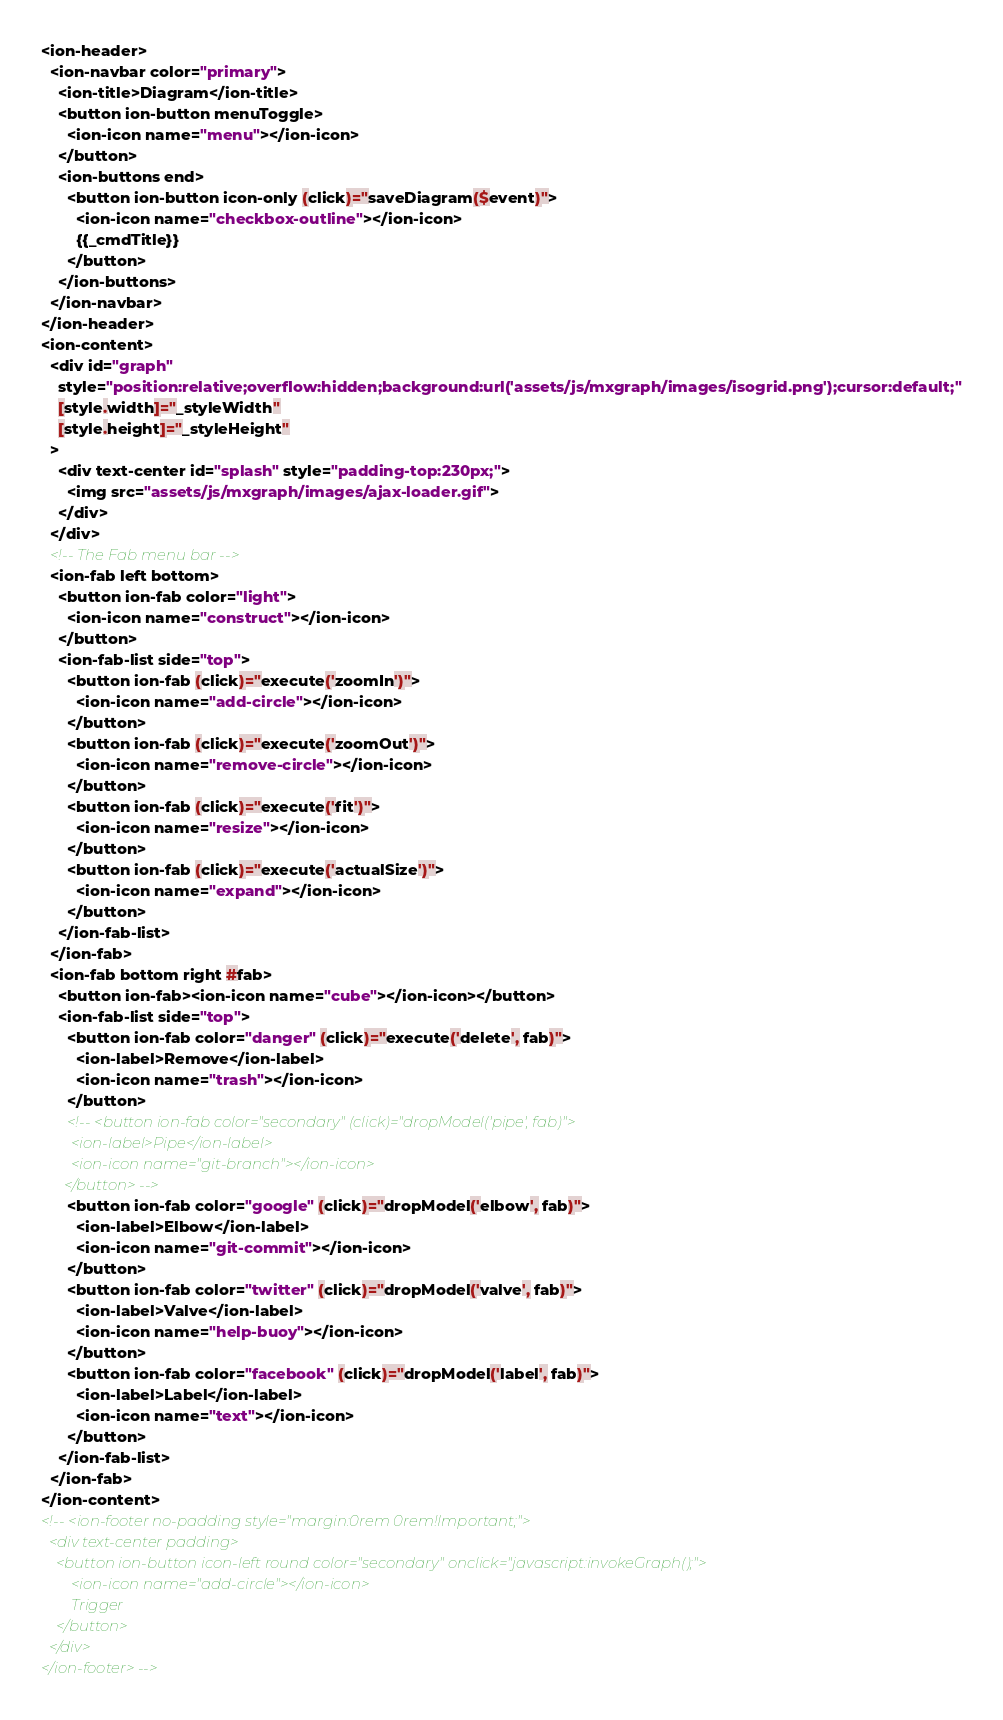<code> <loc_0><loc_0><loc_500><loc_500><_HTML_><ion-header>
  <ion-navbar color="primary">
    <ion-title>Diagram</ion-title>
    <button ion-button menuToggle>
      <ion-icon name="menu"></ion-icon>
    </button>    
    <ion-buttons end>
      <button ion-button icon-only (click)="saveDiagram($event)">
        <ion-icon name="checkbox-outline"></ion-icon>
        {{_cmdTitle}}
      </button>
    </ion-buttons>
  </ion-navbar>
</ion-header> 
<ion-content>
  <div id="graph"
    style="position:relative;overflow:hidden;background:url('assets/js/mxgraph/images/isogrid.png');cursor:default;"
    [style.width]="_styleWidth"
    [style.height]="_styleHeight"    
  >
    <div text-center id="splash" style="padding-top:230px;">
      <img src="assets/js/mxgraph/images/ajax-loader.gif">
    </div>
  </div>
  <!-- The Fab menu bar -->
  <ion-fab left bottom>
    <button ion-fab color="light">
      <ion-icon name="construct"></ion-icon>
    </button>
    <ion-fab-list side="top">
      <button ion-fab (click)="execute('zoomIn')">
        <ion-icon name="add-circle"></ion-icon>
      </button>
      <button ion-fab (click)="execute('zoomOut')">
        <ion-icon name="remove-circle"></ion-icon>
      </button>
      <button ion-fab (click)="execute('fit')">
        <ion-icon name="resize"></ion-icon>
      </button>      
      <button ion-fab (click)="execute('actualSize')">
        <ion-icon name="expand"></ion-icon>
      </button>
    </ion-fab-list>
  </ion-fab>
  <ion-fab bottom right #fab>
    <button ion-fab><ion-icon name="cube"></ion-icon></button>
    <ion-fab-list side="top">
      <button ion-fab color="danger" (click)="execute('delete', fab)">
        <ion-label>Remove</ion-label>
        <ion-icon name="trash"></ion-icon>
      </button>      
      <!-- <button ion-fab color="secondary" (click)="dropModel('pipe', fab)">
        <ion-label>Pipe</ion-label>
        <ion-icon name="git-branch"></ion-icon>
      </button> -->
      <button ion-fab color="google" (click)="dropModel('elbow', fab)">
        <ion-label>Elbow</ion-label>
        <ion-icon name="git-commit"></ion-icon>
      </button>
      <button ion-fab color="twitter" (click)="dropModel('valve', fab)">
        <ion-label>Valve</ion-label>
        <ion-icon name="help-buoy"></ion-icon>
      </button>
      <button ion-fab color="facebook" (click)="dropModel('label', fab)">
        <ion-label>Label</ion-label>
        <ion-icon name="text"></ion-icon>
      </button>
    </ion-fab-list>
  </ion-fab>
</ion-content>
<!-- <ion-footer no-padding style="margin:0rem 0rem!Important;">
  <div text-center padding>
    <button ion-button icon-left round color="secondary" onclick="javascript:invokeGraph();">
        <ion-icon name="add-circle"></ion-icon>
        Trigger
    </button>
  </div>      
</ion-footer> --></code> 